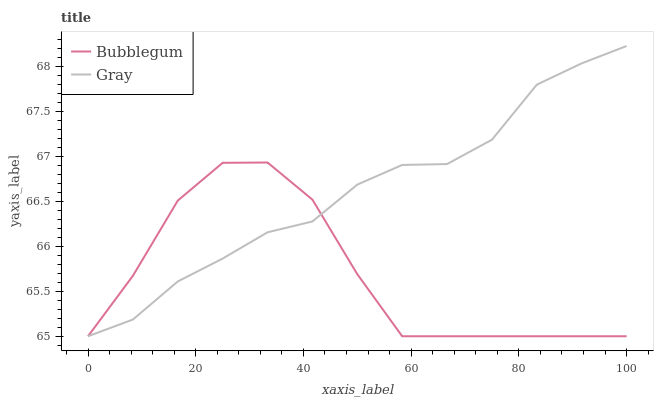Does Bubblegum have the minimum area under the curve?
Answer yes or no. Yes. Does Gray have the maximum area under the curve?
Answer yes or no. Yes. Does Bubblegum have the maximum area under the curve?
Answer yes or no. No. Is Gray the smoothest?
Answer yes or no. Yes. Is Bubblegum the roughest?
Answer yes or no. Yes. Is Bubblegum the smoothest?
Answer yes or no. No. Does Gray have the lowest value?
Answer yes or no. Yes. Does Gray have the highest value?
Answer yes or no. Yes. Does Bubblegum have the highest value?
Answer yes or no. No. Does Gray intersect Bubblegum?
Answer yes or no. Yes. Is Gray less than Bubblegum?
Answer yes or no. No. Is Gray greater than Bubblegum?
Answer yes or no. No. 